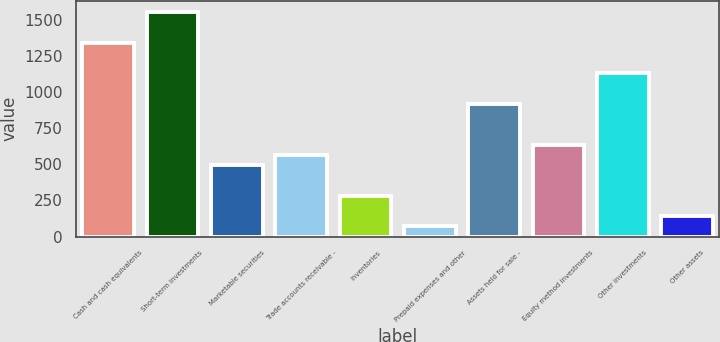Convert chart. <chart><loc_0><loc_0><loc_500><loc_500><bar_chart><fcel>Cash and cash equivalents<fcel>Short-term investments<fcel>Marketable securities<fcel>Trade accounts receivable -<fcel>Inventories<fcel>Prepaid expenses and other<fcel>Assets held for sale -<fcel>Equity method investments<fcel>Other investments<fcel>Other assets<nl><fcel>1344.3<fcel>1556.4<fcel>495.9<fcel>566.6<fcel>283.8<fcel>71.7<fcel>920.1<fcel>637.3<fcel>1132.2<fcel>142.4<nl></chart> 